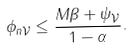Convert formula to latex. <formula><loc_0><loc_0><loc_500><loc_500>\| \phi _ { n } \| _ { \mathcal { V } } \leq \frac { M \beta + \| \psi \| _ { \mathcal { V } } } { 1 - \alpha } .</formula> 